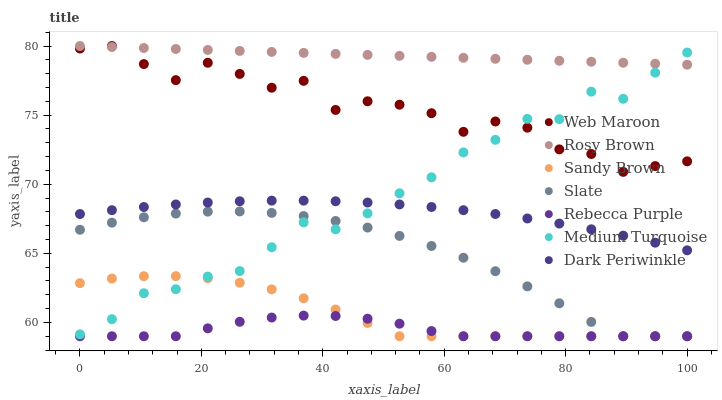Does Rebecca Purple have the minimum area under the curve?
Answer yes or no. Yes. Does Rosy Brown have the maximum area under the curve?
Answer yes or no. Yes. Does Web Maroon have the minimum area under the curve?
Answer yes or no. No. Does Web Maroon have the maximum area under the curve?
Answer yes or no. No. Is Rosy Brown the smoothest?
Answer yes or no. Yes. Is Web Maroon the roughest?
Answer yes or no. Yes. Is Web Maroon the smoothest?
Answer yes or no. No. Is Rosy Brown the roughest?
Answer yes or no. No. Does Slate have the lowest value?
Answer yes or no. Yes. Does Web Maroon have the lowest value?
Answer yes or no. No. Does Web Maroon have the highest value?
Answer yes or no. Yes. Does Rebecca Purple have the highest value?
Answer yes or no. No. Is Rebecca Purple less than Medium Turquoise?
Answer yes or no. Yes. Is Rosy Brown greater than Slate?
Answer yes or no. Yes. Does Web Maroon intersect Rosy Brown?
Answer yes or no. Yes. Is Web Maroon less than Rosy Brown?
Answer yes or no. No. Is Web Maroon greater than Rosy Brown?
Answer yes or no. No. Does Rebecca Purple intersect Medium Turquoise?
Answer yes or no. No. 